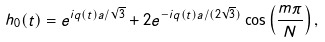<formula> <loc_0><loc_0><loc_500><loc_500>h _ { 0 } ( t ) = e ^ { i q ( t ) a / \sqrt { 3 } } + 2 e ^ { - i q ( t ) a / ( 2 \sqrt { 3 } ) } \cos \left ( \frac { m \pi } { N } \right ) ,</formula> 